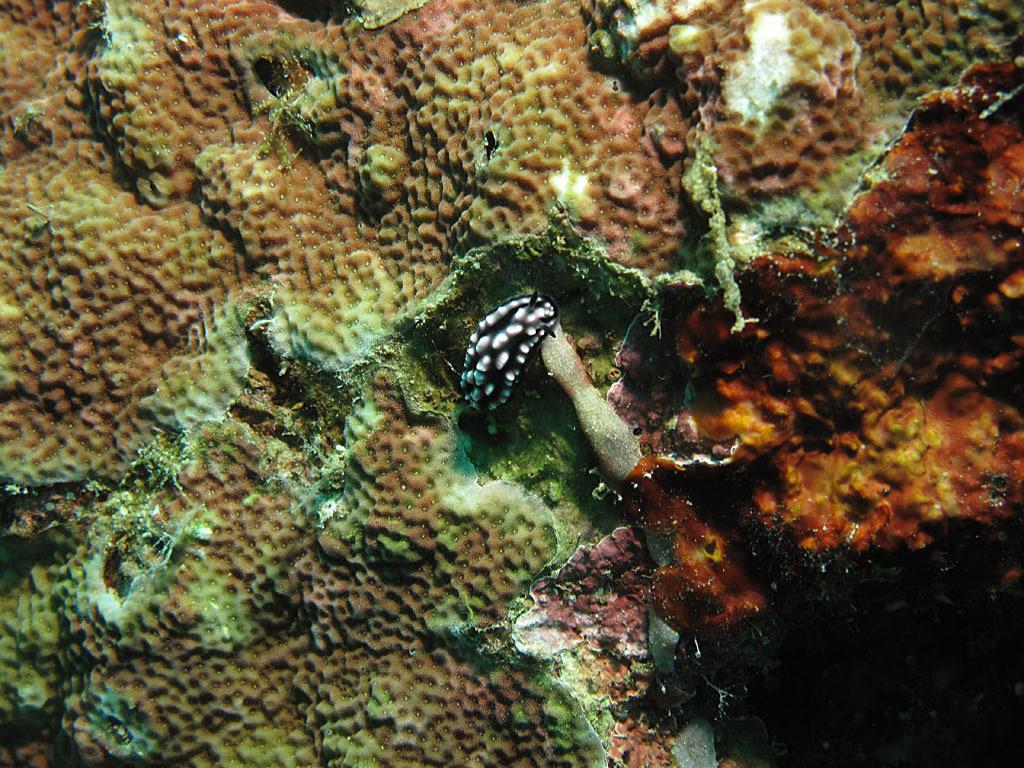Could you give a brief overview of what you see in this image? It seems like an underwater land where we can see an animal. 